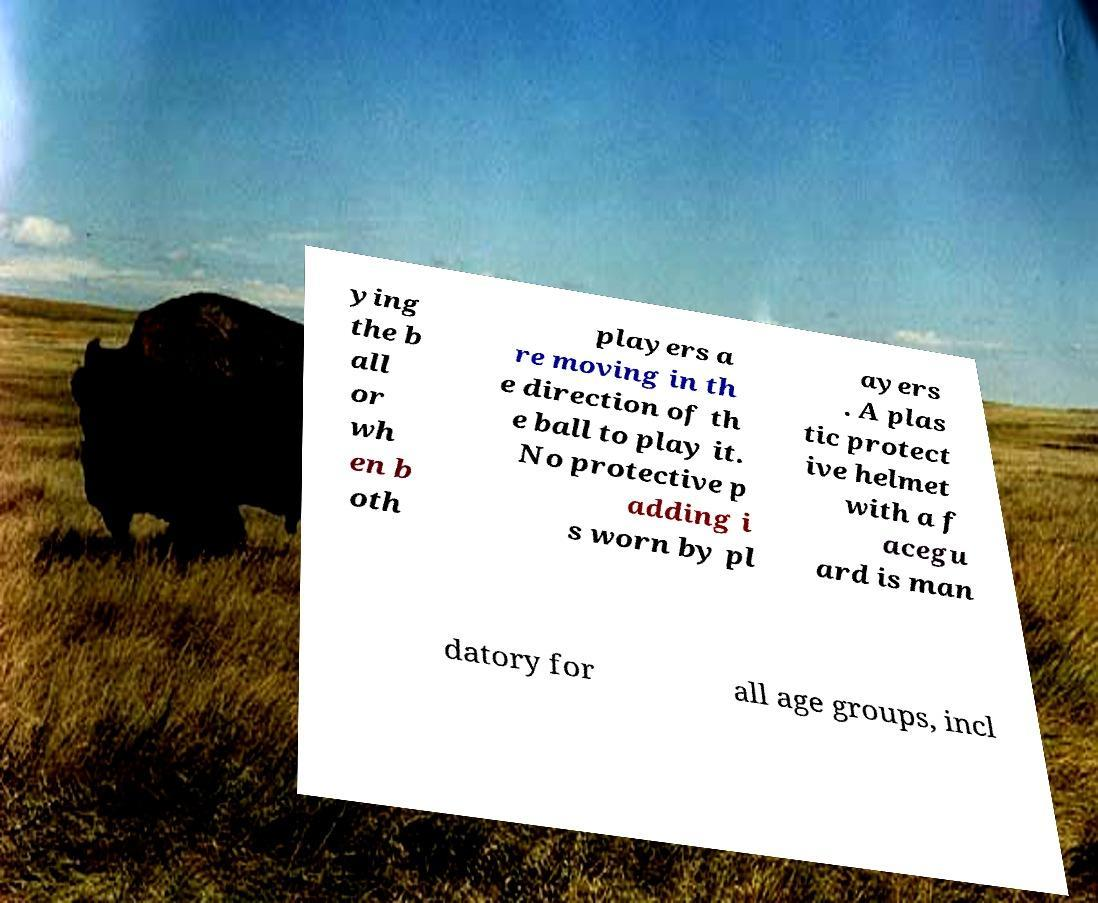Could you assist in decoding the text presented in this image and type it out clearly? ying the b all or wh en b oth players a re moving in th e direction of th e ball to play it. No protective p adding i s worn by pl ayers . A plas tic protect ive helmet with a f acegu ard is man datory for all age groups, incl 